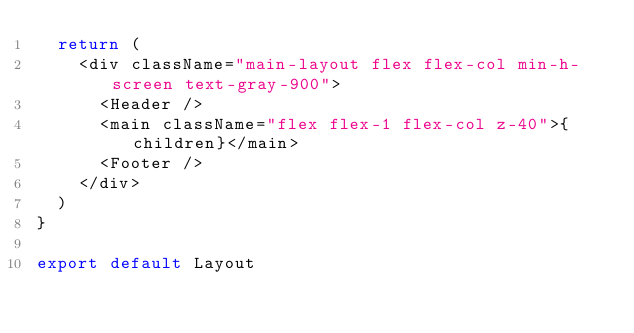Convert code to text. <code><loc_0><loc_0><loc_500><loc_500><_JavaScript_>  return (
    <div className="main-layout flex flex-col min-h-screen text-gray-900">
      <Header />
      <main className="flex flex-1 flex-col z-40">{children}</main>
      <Footer />
    </div>
  )
}

export default Layout</code> 